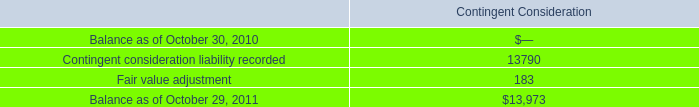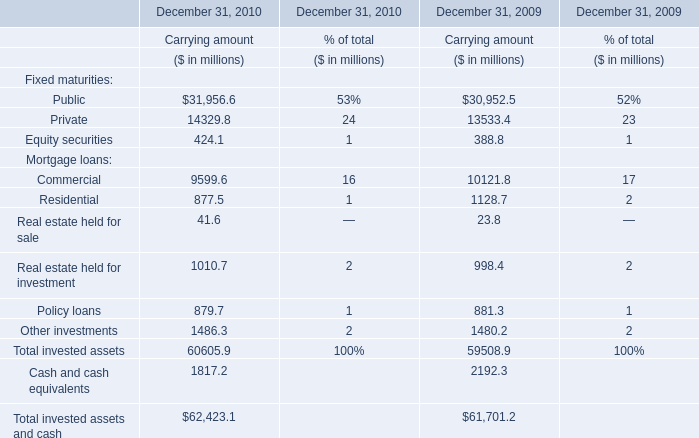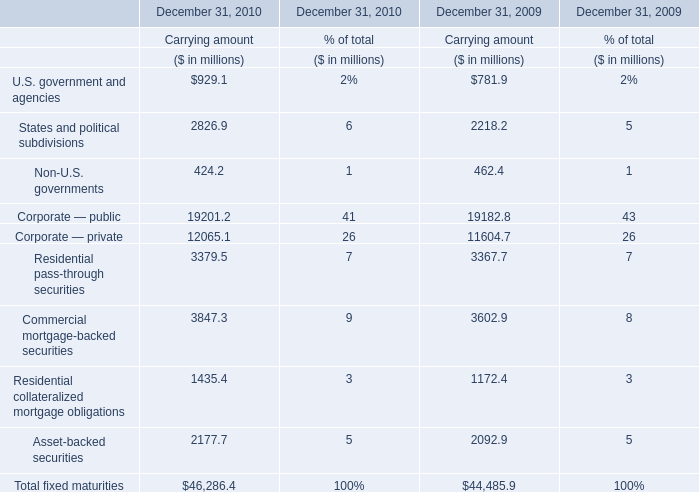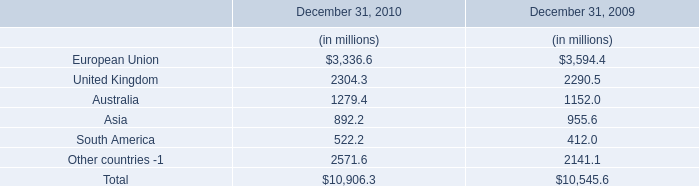what is the net change the fair value of the long-term debt in 2011? 
Computations: (413.4 - 416.3)
Answer: -2.9. 